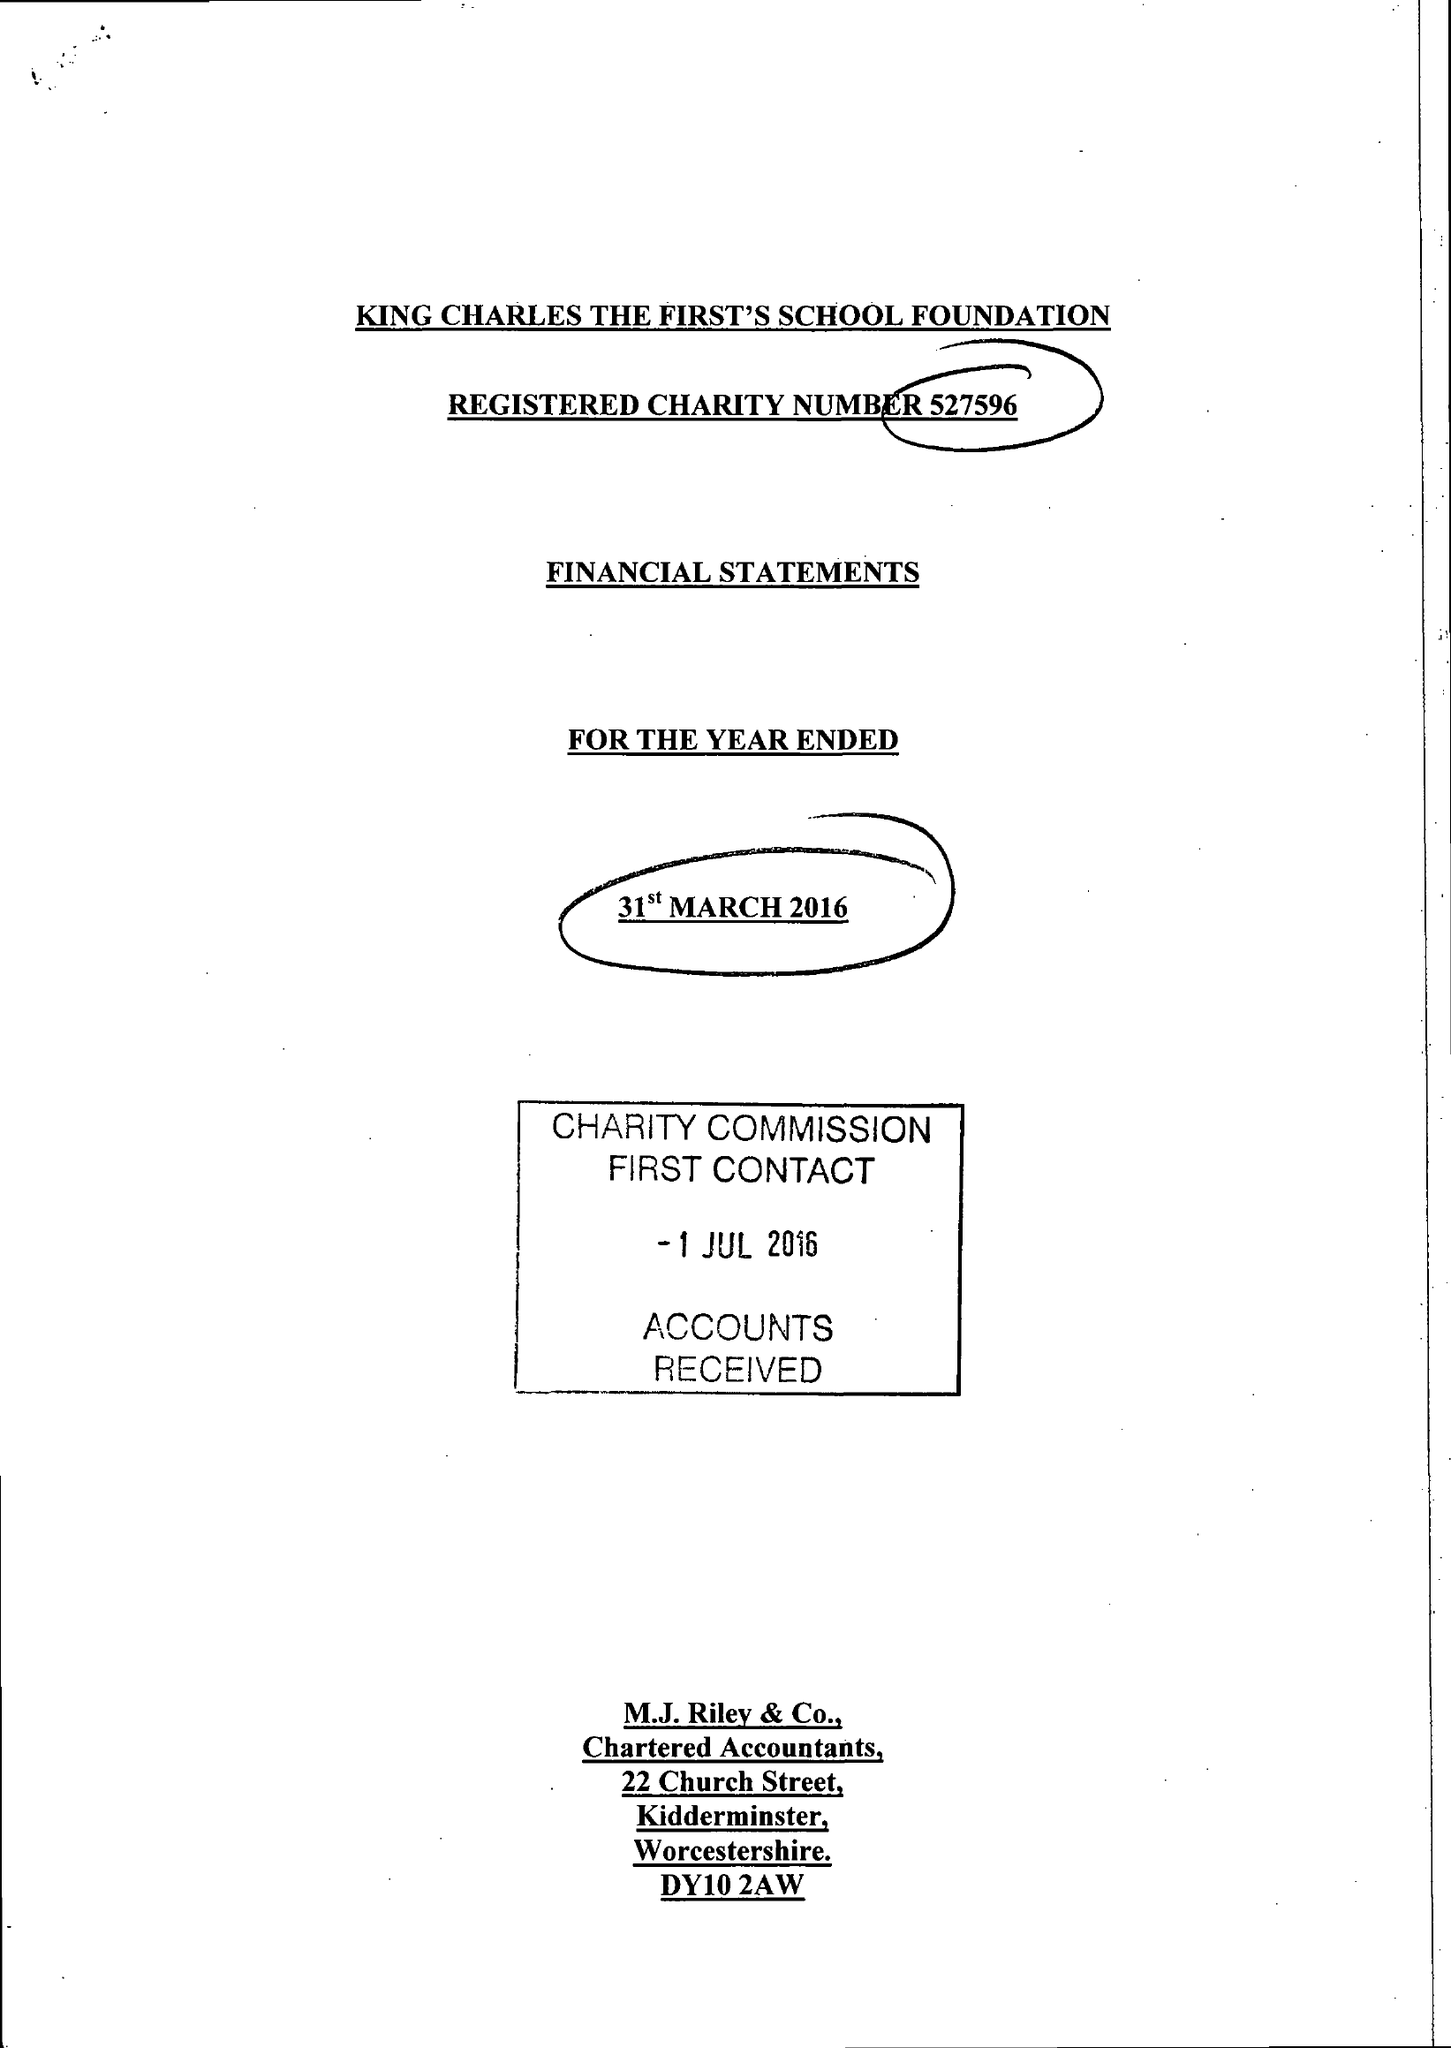What is the value for the address__street_line?
Answer the question using a single word or phrase. WILDEN TOP ROAD 